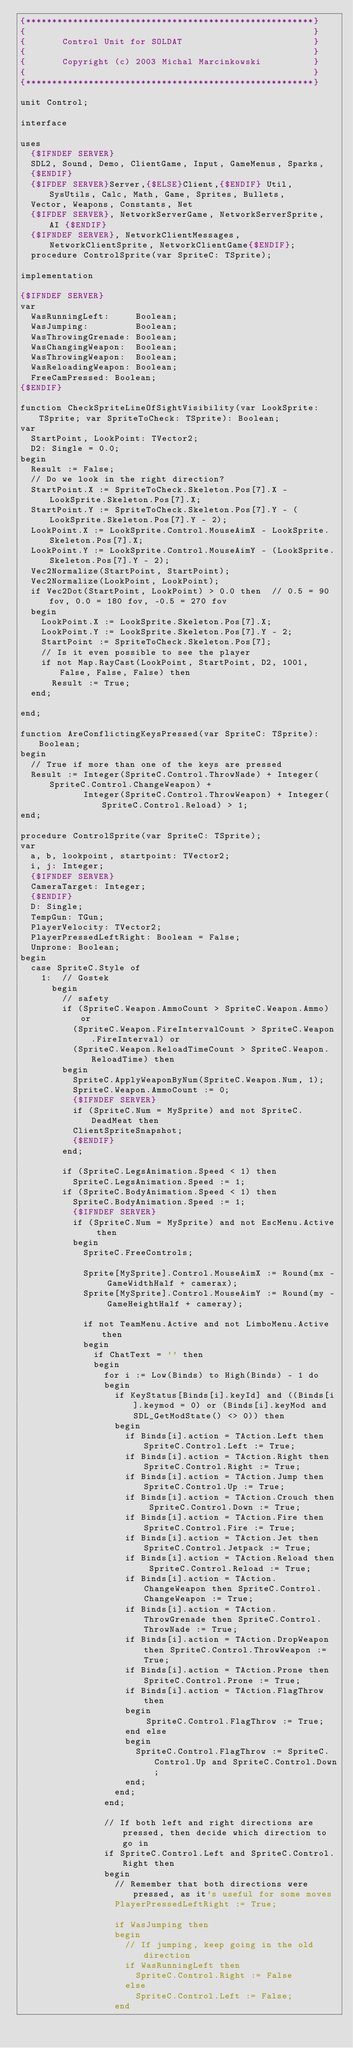<code> <loc_0><loc_0><loc_500><loc_500><_Pascal_>{*******************************************************}
{                                                       }
{       Control Unit for SOLDAT                         }
{                                                       }
{       Copyright (c) 2003 Michal Marcinkowski          }
{                                                       }
{*******************************************************}

unit Control;

interface

uses
  {$IFNDEF SERVER}
  SDL2, Sound, Demo, ClientGame, Input, GameMenus, Sparks,
  {$ENDIF}
  {$IFDEF SERVER}Server,{$ELSE}Client,{$ENDIF} Util, SysUtils, Calc, Math, Game, Sprites, Bullets,
  Vector, Weapons, Constants, Net
  {$IFDEF SERVER}, NetworkServerGame, NetworkServerSprite, AI {$ENDIF}
  {$IFNDEF SERVER}, NetworkClientMessages, NetworkClientSprite, NetworkClientGame{$ENDIF};
  procedure ControlSprite(var SpriteC: TSprite);

implementation

{$IFNDEF SERVER}
var
  WasRunningLeft:     Boolean;
  WasJumping:         Boolean;
  WasThrowingGrenade: Boolean;
  WasChangingWeapon:  Boolean;
  WasThrowingWeapon:  Boolean;
  WasReloadingWeapon: Boolean;
  FreeCamPressed: Boolean;
{$ENDIF}

function CheckSpriteLineOfSightVisibility(var LookSprite: TSprite; var SpriteToCheck: TSprite): Boolean;
var
  StartPoint, LookPoint: TVector2;
  D2: Single = 0.0;
begin
  Result := False;
  // Do we look in the right direction?
  StartPoint.X := SpriteToCheck.Skeleton.Pos[7].X - LookSprite.Skeleton.Pos[7].X;
  StartPoint.Y := SpriteToCheck.Skeleton.Pos[7].Y - (LookSprite.Skeleton.Pos[7].Y - 2);
  LookPoint.X := LookSprite.Control.MouseAimX - LookSprite.Skeleton.Pos[7].X;
  LookPoint.Y := LookSprite.Control.MouseAimY - (LookSprite.Skeleton.Pos[7].Y - 2);
  Vec2Normalize(StartPoint, StartPoint);
  Vec2Normalize(LookPoint, LookPoint);
  if Vec2Dot(StartPoint, LookPoint) > 0.0 then  // 0.5 = 90 fov, 0.0 = 180 fov, -0.5 = 270 fov
  begin
    LookPoint.X := LookSprite.Skeleton.Pos[7].X;
    LookPoint.Y := LookSprite.Skeleton.Pos[7].Y - 2;
    StartPoint := SpriteToCheck.Skeleton.Pos[7];
    // Is it even possible to see the player
    if not Map.RayCast(LookPoint, StartPoint, D2, 1001, False, False, False) then
      Result := True;
  end;

end;

function AreConflictingKeysPressed(var SpriteC: TSprite): Boolean;
begin
  // True if more than one of the keys are pressed
  Result := Integer(SpriteC.Control.ThrowNade) + Integer(SpriteC.Control.ChangeWeapon) +
            Integer(SpriteC.Control.ThrowWeapon) + Integer(SpriteC.Control.Reload) > 1;
end;

procedure ControlSprite(var SpriteC: TSprite);
var
  a, b, lookpoint, startpoint: TVector2;
  i, j: Integer;
  {$IFNDEF SERVER}
  CameraTarget: Integer;
  {$ENDIF}
  D: Single;
  TempGun: TGun;
  PlayerVelocity: TVector2;
  PlayerPressedLeftRight: Boolean = False;
  Unprone: Boolean;
begin
  case SpriteC.Style of
    1:  // Gostek
      begin
        // safety
        if (SpriteC.Weapon.AmmoCount > SpriteC.Weapon.Ammo) or
          (SpriteC.Weapon.FireIntervalCount > SpriteC.Weapon.FireInterval) or
          (SpriteC.Weapon.ReloadTimeCount > SpriteC.Weapon.ReloadTime) then
        begin
          SpriteC.ApplyWeaponByNum(SpriteC.Weapon.Num, 1);
          SpriteC.Weapon.AmmoCount := 0;
          {$IFNDEF SERVER}
          if (SpriteC.Num = MySprite) and not SpriteC.DeadMeat then
          ClientSpriteSnapshot;
          {$ENDIF}
        end;

        if (SpriteC.LegsAnimation.Speed < 1) then
          SpriteC.LegsAnimation.Speed := 1;
        if (SpriteC.BodyAnimation.Speed < 1) then
          SpriteC.BodyAnimation.Speed := 1;
          {$IFNDEF SERVER}
          if (SpriteC.Num = MySprite) and not EscMenu.Active then
          begin
            SpriteC.FreeControls;

            Sprite[MySprite].Control.MouseAimX := Round(mx - GameWidthHalf + camerax);
            Sprite[MySprite].Control.MouseAimY := Round(my - GameHeightHalf + cameray);

            if not TeamMenu.Active and not LimboMenu.Active then
            begin
              if ChatText = '' then
              begin
                for i := Low(Binds) to High(Binds) - 1 do
                begin
                  if KeyStatus[Binds[i].keyId] and ((Binds[i].keymod = 0) or (Binds[i].keyMod and SDL_GetModState() <> 0)) then
                  begin
                    if Binds[i].action = TAction.Left then SpriteC.Control.Left := True;
                    if Binds[i].action = TAction.Right then SpriteC.Control.Right := True;
                    if Binds[i].action = TAction.Jump then SpriteC.Control.Up := True;
                    if Binds[i].action = TAction.Crouch then SpriteC.Control.Down := True;
                    if Binds[i].action = TAction.Fire then SpriteC.Control.Fire := True;
                    if Binds[i].action = TAction.Jet then SpriteC.Control.Jetpack := True;
                    if Binds[i].action = TAction.Reload then SpriteC.Control.Reload := True;
                    if Binds[i].action = TAction.ChangeWeapon then SpriteC.Control.ChangeWeapon := True;
                    if Binds[i].action = TAction.ThrowGrenade then SpriteC.Control.ThrowNade := True;
                    if Binds[i].action = TAction.DropWeapon then SpriteC.Control.ThrowWeapon := True;
                    if Binds[i].action = TAction.Prone then SpriteC.Control.Prone := True;
                    if Binds[i].action = TAction.FlagThrow then
                    begin
                        SpriteC.Control.FlagThrow := True;
                    end else
                    begin
                      SpriteC.Control.FlagThrow := SpriteC.Control.Up and SpriteC.Control.Down;
                    end;
                  end;
                end;

                // If both left and right directions are pressed, then decide which direction to go in
                if SpriteC.Control.Left and SpriteC.Control.Right then
                begin
                  // Remember that both directions were pressed, as it's useful for some moves
                  PlayerPressedLeftRight := True;

                  if WasJumping then
                  begin
                    // If jumping, keep going in the old direction
                    if WasRunningLeft then
                      SpriteC.Control.Right := False
                    else
                      SpriteC.Control.Left := False;
                  end</code> 